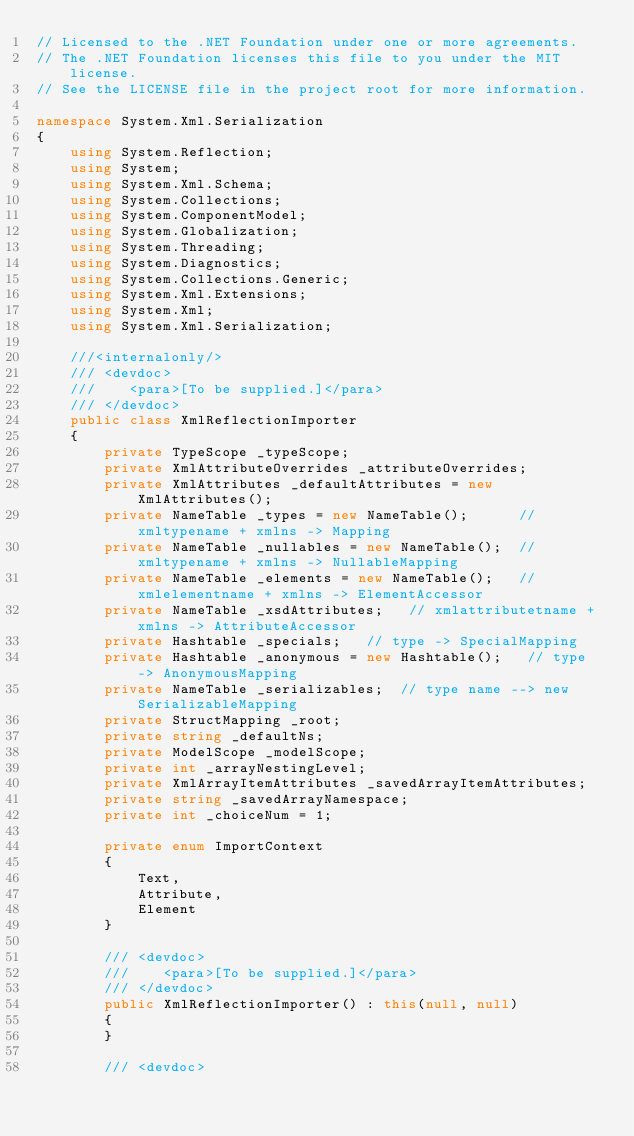Convert code to text. <code><loc_0><loc_0><loc_500><loc_500><_C#_>// Licensed to the .NET Foundation under one or more agreements.
// The .NET Foundation licenses this file to you under the MIT license.
// See the LICENSE file in the project root for more information.

namespace System.Xml.Serialization
{
    using System.Reflection;
    using System;
    using System.Xml.Schema;
    using System.Collections;
    using System.ComponentModel;
    using System.Globalization;
    using System.Threading;
    using System.Diagnostics;
    using System.Collections.Generic;
    using System.Xml.Extensions;
    using System.Xml;
    using System.Xml.Serialization;

    ///<internalonly/>
    /// <devdoc>
    ///    <para>[To be supplied.]</para>
    /// </devdoc>
    public class XmlReflectionImporter
    {
        private TypeScope _typeScope;
        private XmlAttributeOverrides _attributeOverrides;
        private XmlAttributes _defaultAttributes = new XmlAttributes();
        private NameTable _types = new NameTable();      // xmltypename + xmlns -> Mapping
        private NameTable _nullables = new NameTable();  // xmltypename + xmlns -> NullableMapping
        private NameTable _elements = new NameTable();   // xmlelementname + xmlns -> ElementAccessor
        private NameTable _xsdAttributes;   // xmlattributetname + xmlns -> AttributeAccessor
        private Hashtable _specials;   // type -> SpecialMapping
        private Hashtable _anonymous = new Hashtable();   // type -> AnonymousMapping
        private NameTable _serializables;  // type name --> new SerializableMapping
        private StructMapping _root;
        private string _defaultNs;
        private ModelScope _modelScope;
        private int _arrayNestingLevel;
        private XmlArrayItemAttributes _savedArrayItemAttributes;
        private string _savedArrayNamespace;
        private int _choiceNum = 1;

        private enum ImportContext
        {
            Text,
            Attribute,
            Element
        }

        /// <devdoc>
        ///    <para>[To be supplied.]</para>
        /// </devdoc>
        public XmlReflectionImporter() : this(null, null)
        {
        }

        /// <devdoc></code> 